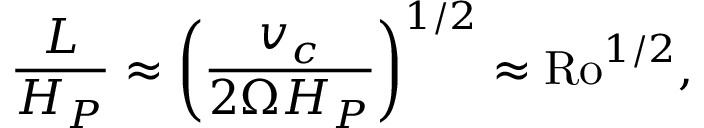<formula> <loc_0><loc_0><loc_500><loc_500>{ \frac { L } { H _ { P } } } \approx \left ( { \frac { v _ { c } } { 2 \Omega H _ { P } } } \right ) ^ { 1 / 2 } \approx R o ^ { 1 / 2 } ,</formula> 